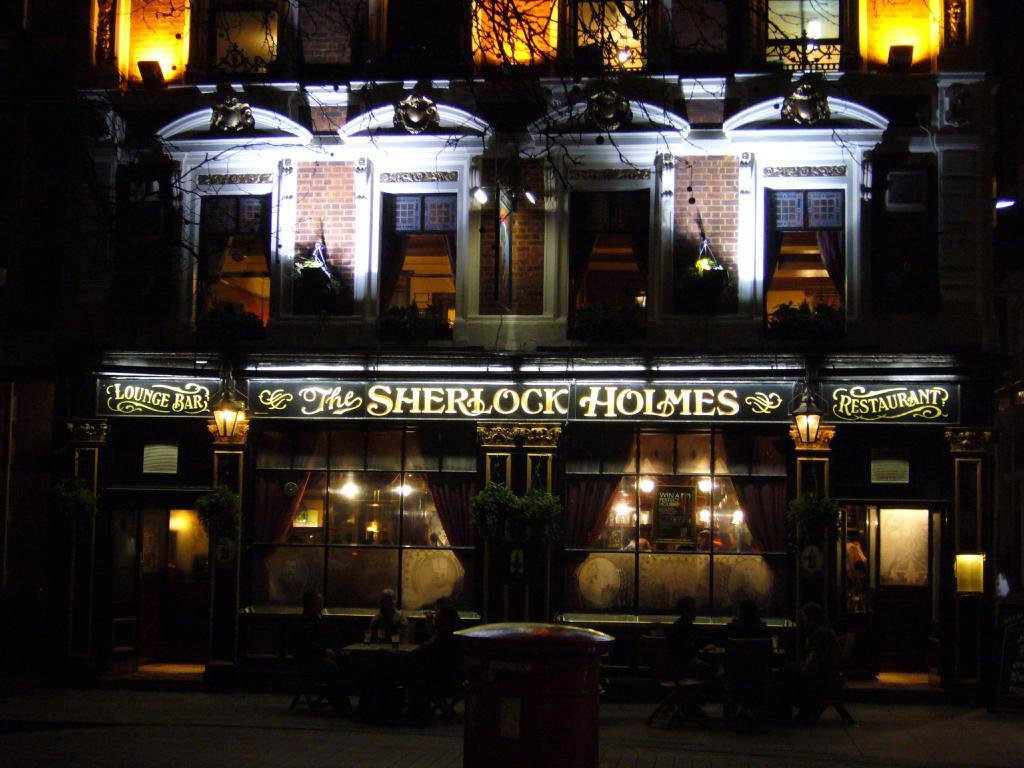What type of structure is present in the image? There is a building in the image. What features can be observed on the building? The building has windows and lights. Are there any signs or messages visible in the image? Yes, there are boards with writing on them in the image. What type of natural element is present in the image? There is a tree in the image. How would you describe the lighting conditions in the image? The image is dark. How many cherries are hanging from the tree in the image? There are no cherries present in the image; it only features a tree. Can you describe the car parked near the building in the image? There is no car present in the image; only a building, boards with writing, a tree, and lights are visible. 